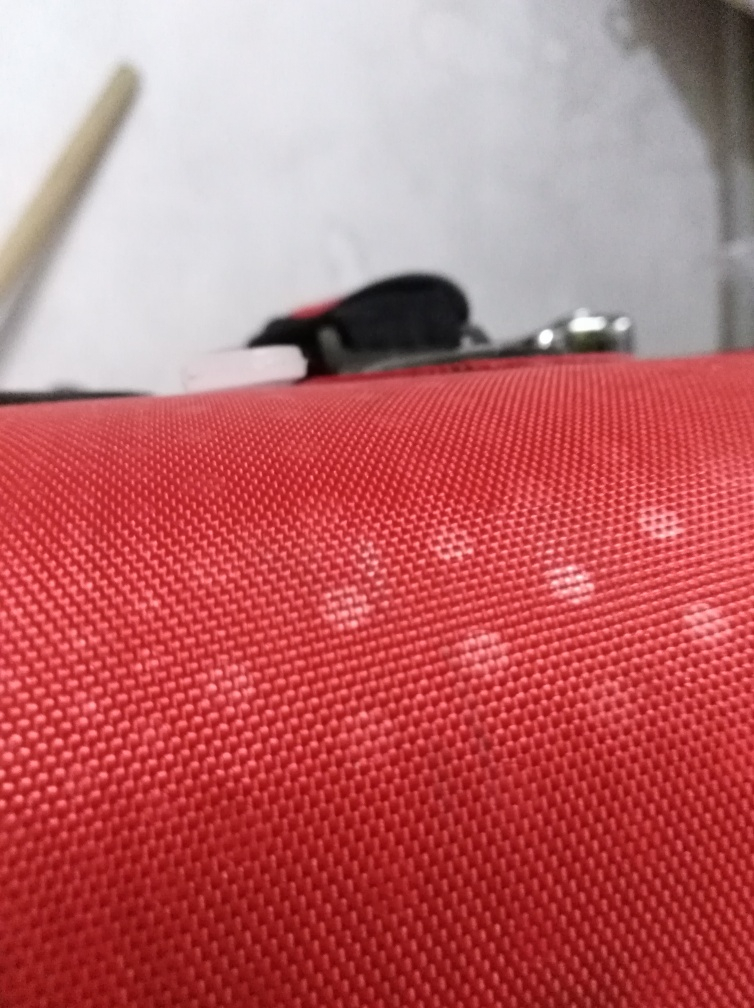Is the image of high quality? The photo appears to be of lower quality due to a lack of sharpness, the presence of blur, and suboptimal lighting conditions that contribute to a grainy texture. The main subject of the photo is not clearly defined, which suggests that it may have been taken hastily or without careful attention to composition and focus. 